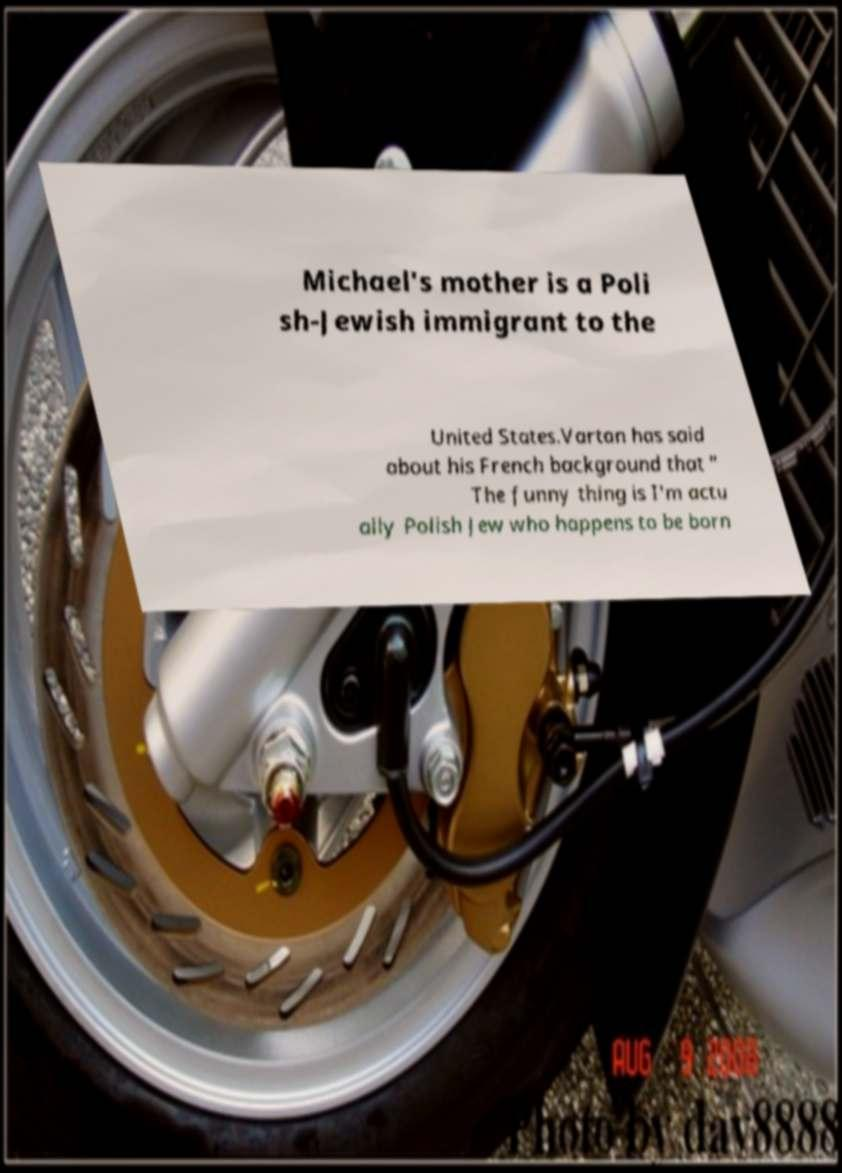What messages or text are displayed in this image? I need them in a readable, typed format. Michael's mother is a Poli sh-Jewish immigrant to the United States.Vartan has said about his French background that " The funny thing is I'm actu ally Polish Jew who happens to be born 